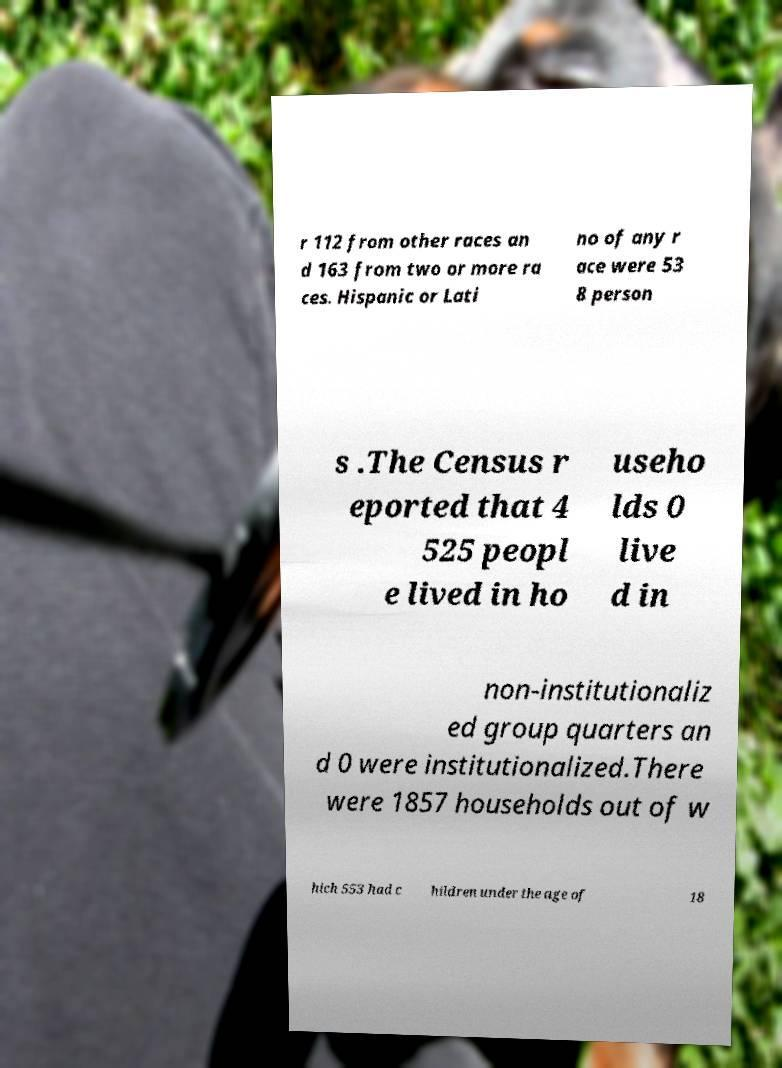Can you read and provide the text displayed in the image?This photo seems to have some interesting text. Can you extract and type it out for me? r 112 from other races an d 163 from two or more ra ces. Hispanic or Lati no of any r ace were 53 8 person s .The Census r eported that 4 525 peopl e lived in ho useho lds 0 live d in non-institutionaliz ed group quarters an d 0 were institutionalized.There were 1857 households out of w hich 553 had c hildren under the age of 18 